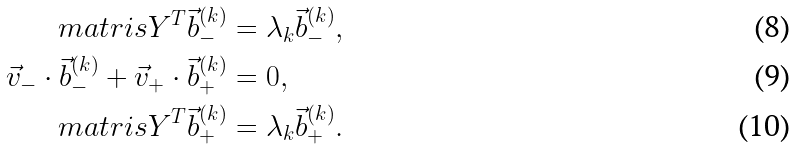<formula> <loc_0><loc_0><loc_500><loc_500>\ m a t r i s { Y } ^ { T } \vec { b } _ { - } ^ { ( k ) } & = \lambda _ { k } \vec { b } _ { - } ^ { ( k ) } , \\ \vec { v } _ { - } \cdot \vec { b } _ { - } ^ { ( k ) } + \vec { v } _ { + } \cdot \vec { b } _ { + } ^ { ( k ) } & = 0 , \\ \ m a t r i s { Y } ^ { T } \vec { b } _ { + } ^ { ( k ) } & = \lambda _ { k } \vec { b } _ { + } ^ { ( k ) } .</formula> 